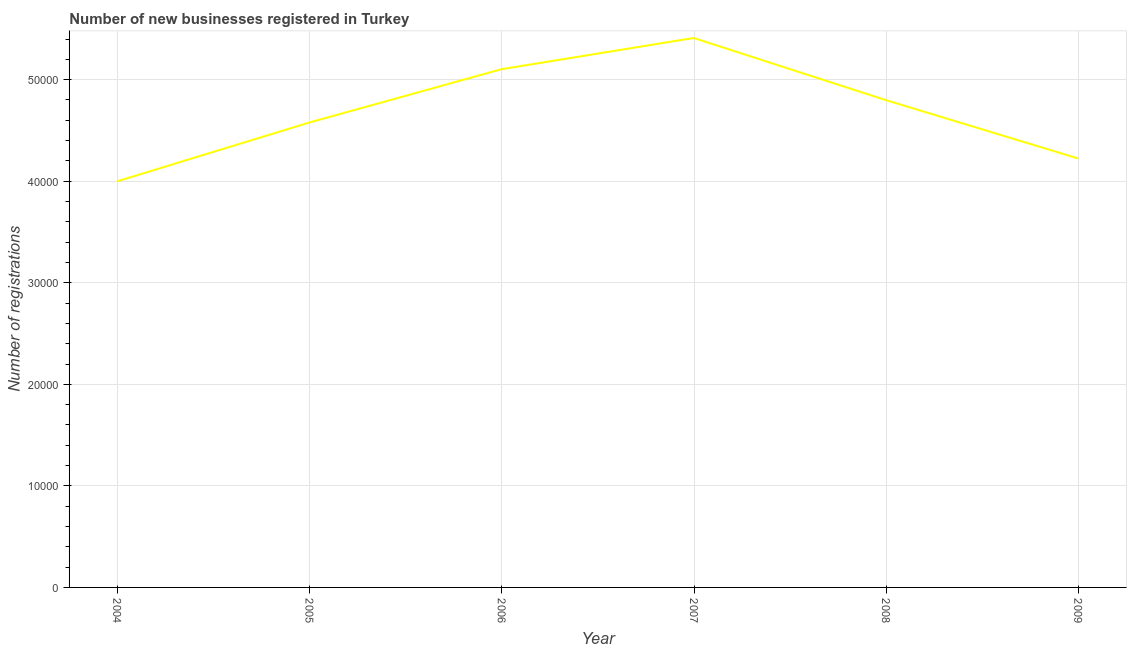What is the number of new business registrations in 2009?
Ensure brevity in your answer.  4.22e+04. Across all years, what is the maximum number of new business registrations?
Offer a very short reply. 5.41e+04. Across all years, what is the minimum number of new business registrations?
Provide a succinct answer. 4.00e+04. In which year was the number of new business registrations maximum?
Ensure brevity in your answer.  2007. What is the sum of the number of new business registrations?
Provide a short and direct response. 2.81e+05. What is the difference between the number of new business registrations in 2005 and 2009?
Provide a short and direct response. 3538. What is the average number of new business registrations per year?
Ensure brevity in your answer.  4.69e+04. What is the median number of new business registrations?
Your answer should be compact. 4.69e+04. In how many years, is the number of new business registrations greater than 34000 ?
Keep it short and to the point. 6. What is the ratio of the number of new business registrations in 2004 to that in 2009?
Make the answer very short. 0.95. Is the number of new business registrations in 2004 less than that in 2007?
Make the answer very short. Yes. What is the difference between the highest and the second highest number of new business registrations?
Offer a terse response. 3074. Is the sum of the number of new business registrations in 2004 and 2006 greater than the maximum number of new business registrations across all years?
Your answer should be very brief. Yes. What is the difference between the highest and the lowest number of new business registrations?
Give a very brief answer. 1.41e+04. How many lines are there?
Provide a short and direct response. 1. What is the difference between two consecutive major ticks on the Y-axis?
Give a very brief answer. 10000. Are the values on the major ticks of Y-axis written in scientific E-notation?
Offer a very short reply. No. What is the title of the graph?
Provide a short and direct response. Number of new businesses registered in Turkey. What is the label or title of the X-axis?
Provide a succinct answer. Year. What is the label or title of the Y-axis?
Keep it short and to the point. Number of registrations. What is the Number of registrations of 2004?
Provide a short and direct response. 4.00e+04. What is the Number of registrations of 2005?
Keep it short and to the point. 4.58e+04. What is the Number of registrations of 2006?
Make the answer very short. 5.10e+04. What is the Number of registrations of 2007?
Offer a terse response. 5.41e+04. What is the Number of registrations of 2008?
Ensure brevity in your answer.  4.80e+04. What is the Number of registrations in 2009?
Offer a terse response. 4.22e+04. What is the difference between the Number of registrations in 2004 and 2005?
Your response must be concise. -5791. What is the difference between the Number of registrations in 2004 and 2006?
Offer a terse response. -1.10e+04. What is the difference between the Number of registrations in 2004 and 2007?
Ensure brevity in your answer.  -1.41e+04. What is the difference between the Number of registrations in 2004 and 2008?
Offer a very short reply. -7999. What is the difference between the Number of registrations in 2004 and 2009?
Your answer should be compact. -2253. What is the difference between the Number of registrations in 2005 and 2006?
Your answer should be very brief. -5252. What is the difference between the Number of registrations in 2005 and 2007?
Your answer should be compact. -8326. What is the difference between the Number of registrations in 2005 and 2008?
Your answer should be compact. -2208. What is the difference between the Number of registrations in 2005 and 2009?
Ensure brevity in your answer.  3538. What is the difference between the Number of registrations in 2006 and 2007?
Provide a short and direct response. -3074. What is the difference between the Number of registrations in 2006 and 2008?
Ensure brevity in your answer.  3044. What is the difference between the Number of registrations in 2006 and 2009?
Your answer should be compact. 8790. What is the difference between the Number of registrations in 2007 and 2008?
Offer a terse response. 6118. What is the difference between the Number of registrations in 2007 and 2009?
Offer a terse response. 1.19e+04. What is the difference between the Number of registrations in 2008 and 2009?
Provide a short and direct response. 5746. What is the ratio of the Number of registrations in 2004 to that in 2005?
Your answer should be compact. 0.87. What is the ratio of the Number of registrations in 2004 to that in 2006?
Your response must be concise. 0.78. What is the ratio of the Number of registrations in 2004 to that in 2007?
Give a very brief answer. 0.74. What is the ratio of the Number of registrations in 2004 to that in 2008?
Provide a short and direct response. 0.83. What is the ratio of the Number of registrations in 2004 to that in 2009?
Offer a very short reply. 0.95. What is the ratio of the Number of registrations in 2005 to that in 2006?
Your answer should be compact. 0.9. What is the ratio of the Number of registrations in 2005 to that in 2007?
Give a very brief answer. 0.85. What is the ratio of the Number of registrations in 2005 to that in 2008?
Offer a terse response. 0.95. What is the ratio of the Number of registrations in 2005 to that in 2009?
Keep it short and to the point. 1.08. What is the ratio of the Number of registrations in 2006 to that in 2007?
Give a very brief answer. 0.94. What is the ratio of the Number of registrations in 2006 to that in 2008?
Your answer should be compact. 1.06. What is the ratio of the Number of registrations in 2006 to that in 2009?
Provide a short and direct response. 1.21. What is the ratio of the Number of registrations in 2007 to that in 2008?
Make the answer very short. 1.13. What is the ratio of the Number of registrations in 2007 to that in 2009?
Your response must be concise. 1.28. What is the ratio of the Number of registrations in 2008 to that in 2009?
Your answer should be very brief. 1.14. 